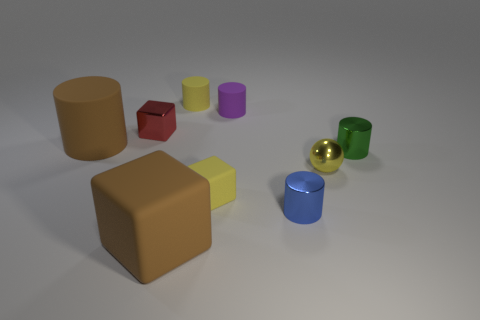Are there any other things that have the same material as the small yellow cube?
Provide a short and direct response. Yes. What number of metallic spheres are to the right of the brown matte object that is behind the blue metallic cylinder?
Your answer should be very brief. 1. What shape is the small yellow thing that is the same material as the tiny red block?
Your answer should be compact. Sphere. How many yellow objects are either large metallic spheres or metal objects?
Provide a short and direct response. 1. There is a big thing that is in front of the big thing behind the large rubber block; is there a thing in front of it?
Provide a succinct answer. No. Is the number of small gray rubber balls less than the number of tiny metal spheres?
Your response must be concise. Yes. Is the shape of the tiny thing to the left of the big matte cube the same as  the blue thing?
Ensure brevity in your answer.  No. Are there any tiny green rubber blocks?
Offer a terse response. No. What color is the tiny cylinder that is to the left of the tiny purple cylinder that is on the left side of the shiny thing on the right side of the shiny ball?
Give a very brief answer. Yellow. Are there an equal number of small blue cylinders that are to the left of the brown cylinder and cubes on the left side of the metallic cube?
Offer a very short reply. Yes. 